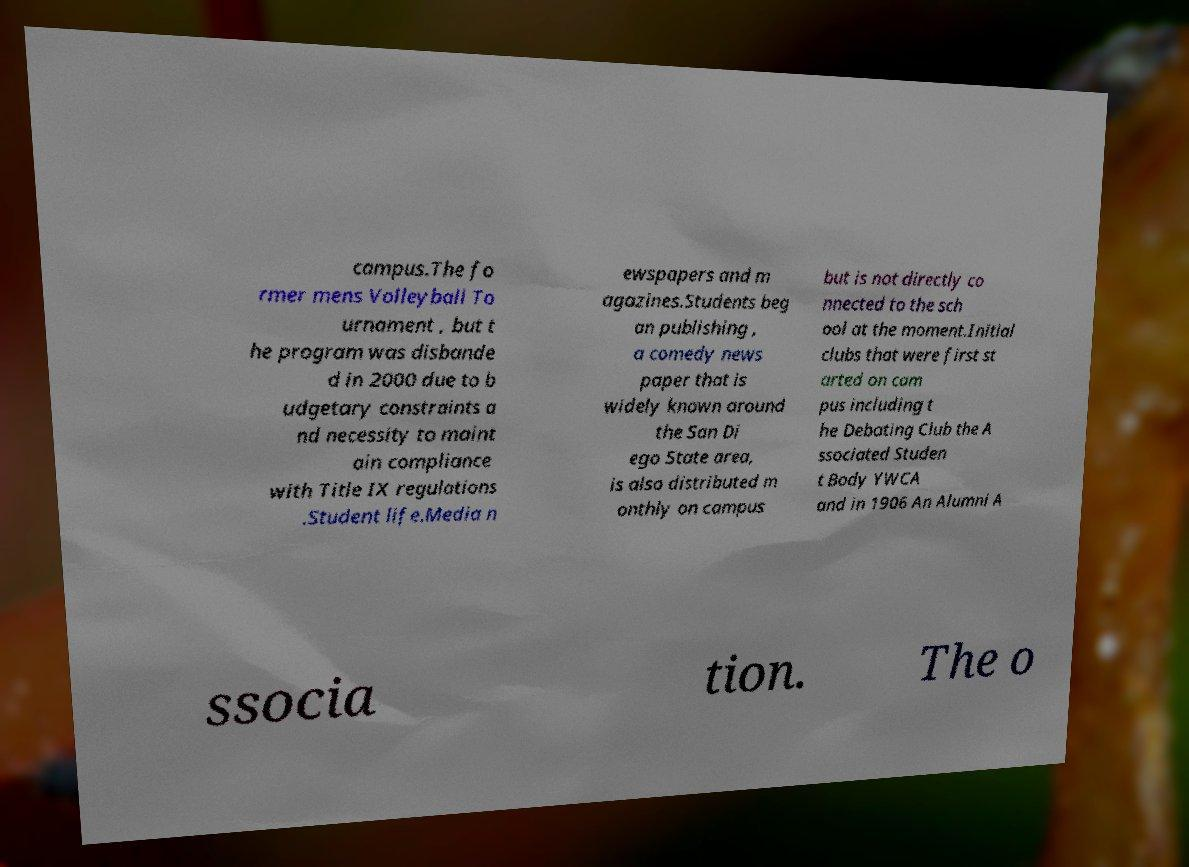What messages or text are displayed in this image? I need them in a readable, typed format. campus.The fo rmer mens Volleyball To urnament , but t he program was disbande d in 2000 due to b udgetary constraints a nd necessity to maint ain compliance with Title IX regulations .Student life.Media n ewspapers and m agazines.Students beg an publishing , a comedy news paper that is widely known around the San Di ego State area, is also distributed m onthly on campus but is not directly co nnected to the sch ool at the moment.Initial clubs that were first st arted on cam pus including t he Debating Club the A ssociated Studen t Body YWCA and in 1906 An Alumni A ssocia tion. The o 